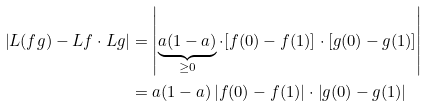<formula> <loc_0><loc_0><loc_500><loc_500>\left | L ( f g ) - L f \cdot L g \right | & = \left | \underbrace { a ( 1 - a ) } _ { \geq 0 } \cdot [ f ( 0 ) - f ( 1 ) ] \cdot [ g ( 0 ) - g ( 1 ) ] \right | \\ & = a ( 1 - a ) \left | f ( 0 ) - f ( 1 ) \right | \cdot \left | g ( 0 ) - g ( 1 ) \right |</formula> 